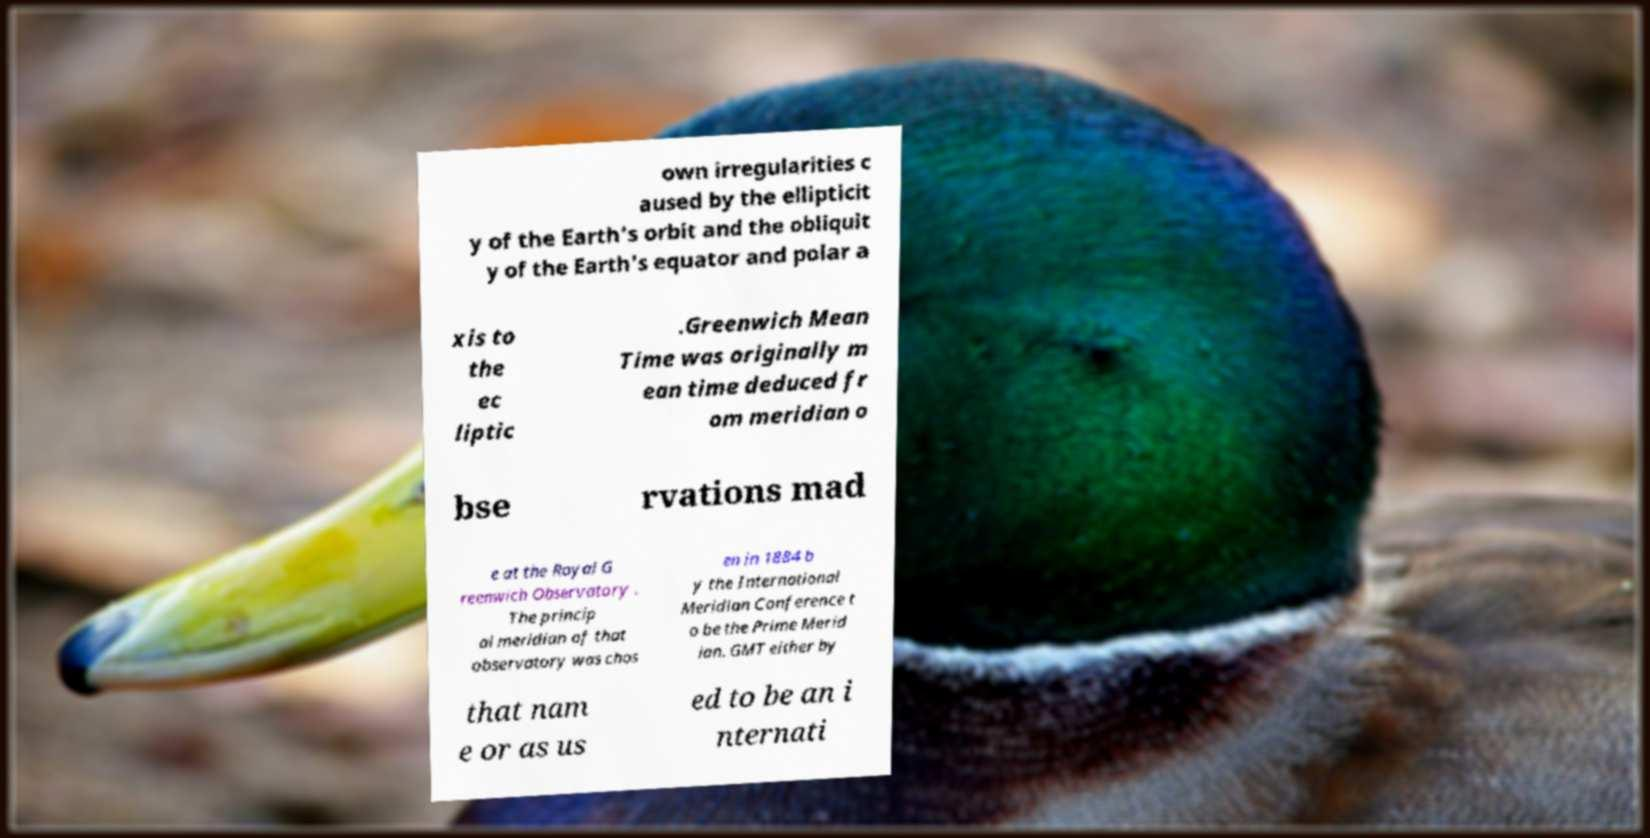What messages or text are displayed in this image? I need them in a readable, typed format. own irregularities c aused by the ellipticit y of the Earth's orbit and the obliquit y of the Earth's equator and polar a xis to the ec liptic .Greenwich Mean Time was originally m ean time deduced fr om meridian o bse rvations mad e at the Royal G reenwich Observatory . The princip al meridian of that observatory was chos en in 1884 b y the International Meridian Conference t o be the Prime Merid ian. GMT either by that nam e or as us ed to be an i nternati 